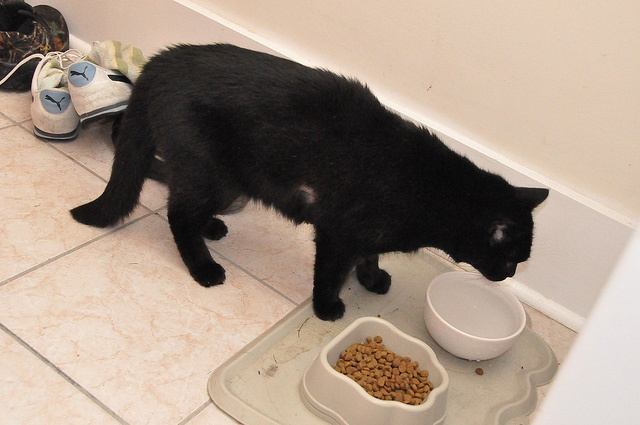Describe the objects in this image and their specific colors. I can see cat in black, tan, and lightgray tones, bowl in black, tan, and brown tones, and bowl in black, tan, darkgray, gray, and lightgray tones in this image. 